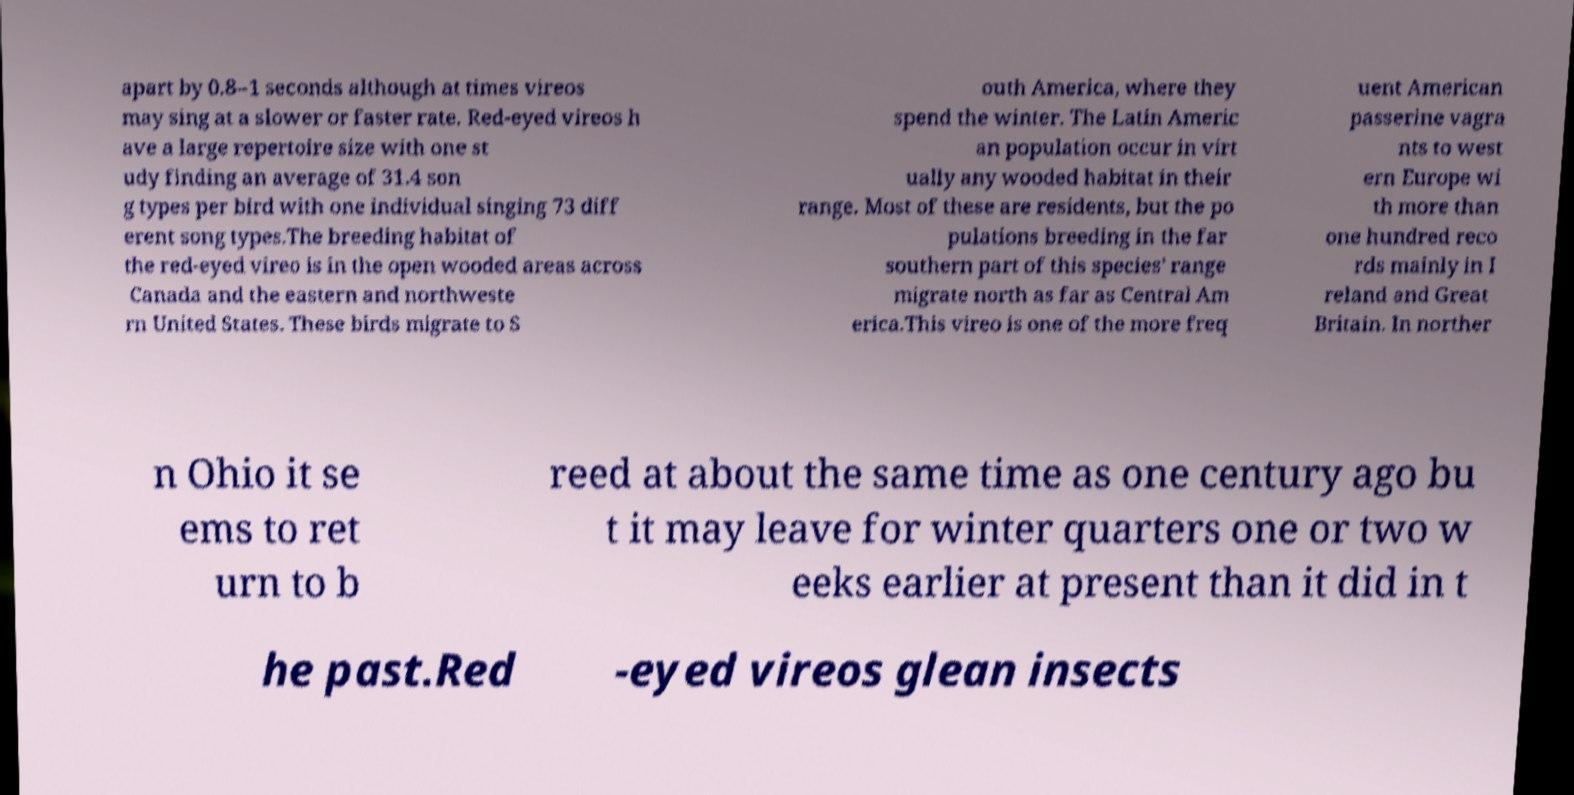Can you read and provide the text displayed in the image?This photo seems to have some interesting text. Can you extract and type it out for me? apart by 0.8–1 seconds although at times vireos may sing at a slower or faster rate. Red-eyed vireos h ave a large repertoire size with one st udy finding an average of 31.4 son g types per bird with one individual singing 73 diff erent song types.The breeding habitat of the red-eyed vireo is in the open wooded areas across Canada and the eastern and northweste rn United States. These birds migrate to S outh America, where they spend the winter. The Latin Americ an population occur in virt ually any wooded habitat in their range. Most of these are residents, but the po pulations breeding in the far southern part of this species' range migrate north as far as Central Am erica.This vireo is one of the more freq uent American passerine vagra nts to west ern Europe wi th more than one hundred reco rds mainly in I reland and Great Britain. In norther n Ohio it se ems to ret urn to b reed at about the same time as one century ago bu t it may leave for winter quarters one or two w eeks earlier at present than it did in t he past.Red -eyed vireos glean insects 